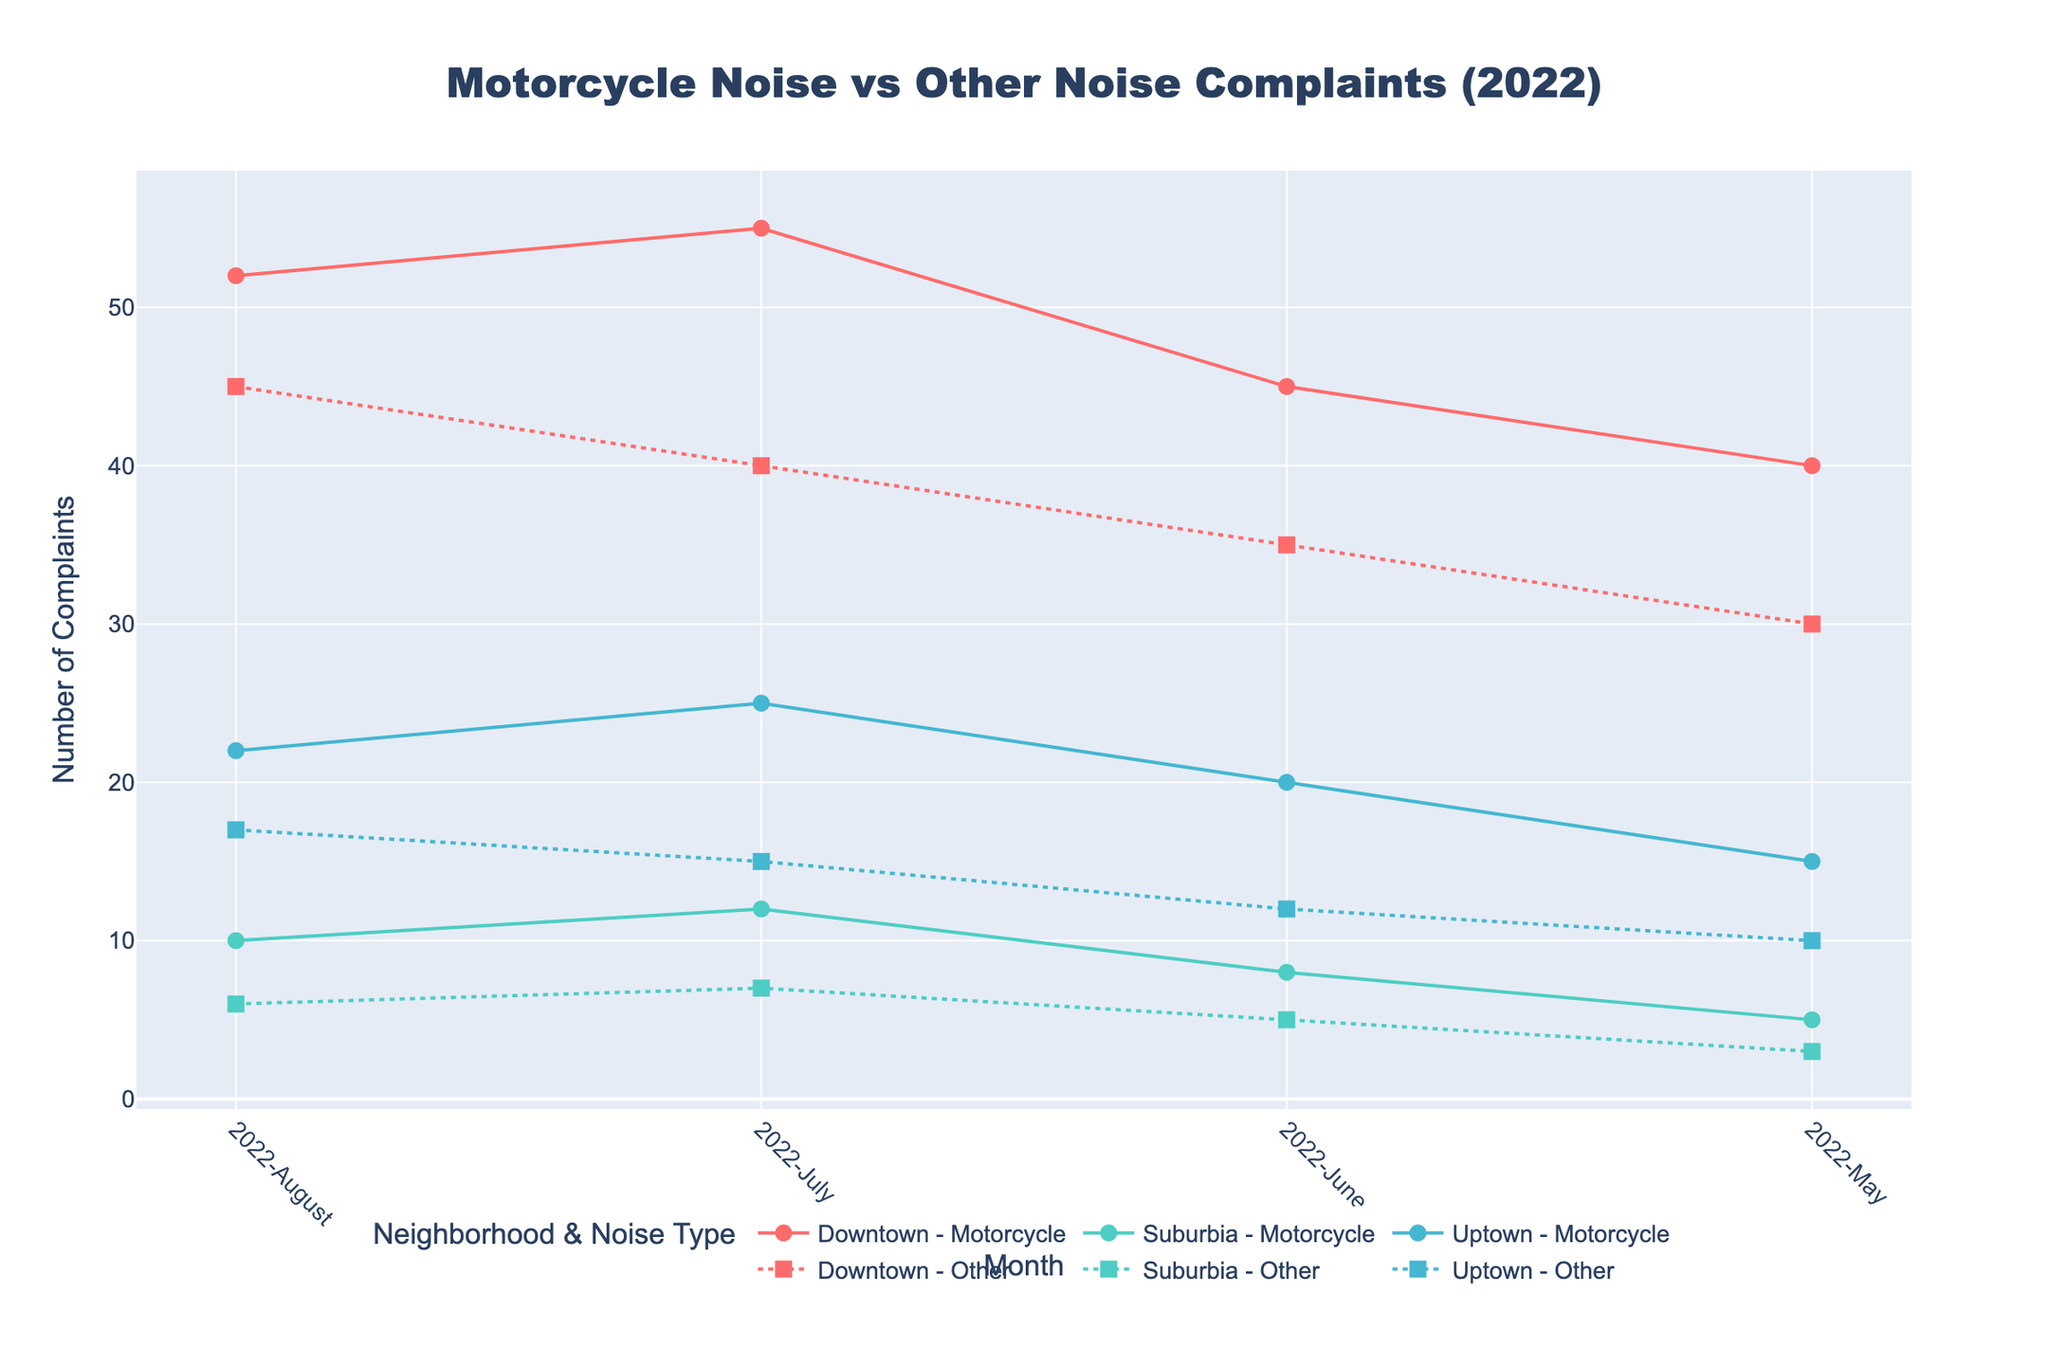What's the title of the figure? The title is usually displayed at the top of the figure and provides a brief description of what the figure represents. By examining the top of the figure, we can see the exact title.
Answer: Motorcycle Noise vs Other Noise Complaints (2022) Which neighborhood has the highest number of motorcycle noise complaints in July 2022? The plot will show markers or lines for each neighborhood's complaints. By locating July 2022 on the x-axis and checking the corresponding y-values for each neighborhood, we identify Downtown as having the highest number of motorcycle noise complaints.
Answer: Downtown How do complaints about motorcycle noise in Suburbia in August 2022 compare to those in May 2022? To compare these months, you need to find the data points for May and August 2022 for Suburbia on the plot. The plot shows 5 complaints in May and 10 complaints in August.
Answer: Complaints doubled from 5 to 10 What is the pattern of motorcycle noise complaints in Uptown from May to August 2022? Examine the data points for Uptown for each month from May to August. By following the line connecting the dots, you can observe the trend: complaints increased from 15 in May to 20 in June, then 25 in July, and finally slightly decreased to 22 in August.
Answer: Generally increasing, with a slight decrease in August Which neighborhood shows a difference between motorcycle and other noise complaints for each month? By examining the markers and lines for both noise types in each neighborhood, we can see that Downtown consistently has higher motorcycle noise complaints than other noise complaints, while a smaller gap exists in Uptown, and an even smaller gap in Suburbia.
Answer: Downtown What is the total number of motorcycle noise complaints in Downtown for the four months displayed? Sum the individual complaints from May to August for Downtown's motorcycle noise. Adding 40, 45, 55, and 52, you get a total of 192.
Answer: 192 Did the number of other noise complaints in Suburbia ever exceed the number of motorcycle noise complaints from May to August 2022? Compare each month's complaints for other noise versus motorcycle noise in Suburbia. For all four months, motorcycle noise complaints are higher than other noise complaints (May: 5 vs 3, June: 8 vs 5, July: 12 vs 7, August: 10 vs 6).
Answer: No During which month were the complaints about motorcycle noise highest in each neighborhood? Examine the lines for each neighborhood and locate the highest points. Check the corresponding months: Downtown has the highest in July, Uptown in July, and Suburbia in July.
Answer: July What is the average number of motorcycle noise complaints across all neighborhoods for June 2022? Sum the motorcycle noise complaints for all neighborhoods in June: Downtown (45), Uptown (20), Suburbia (8). Total = 45 + 20 + 8 = 73. Divide by the number of neighborhoods (3). 73 / 3 = 24.33.
Answer: 24.33 